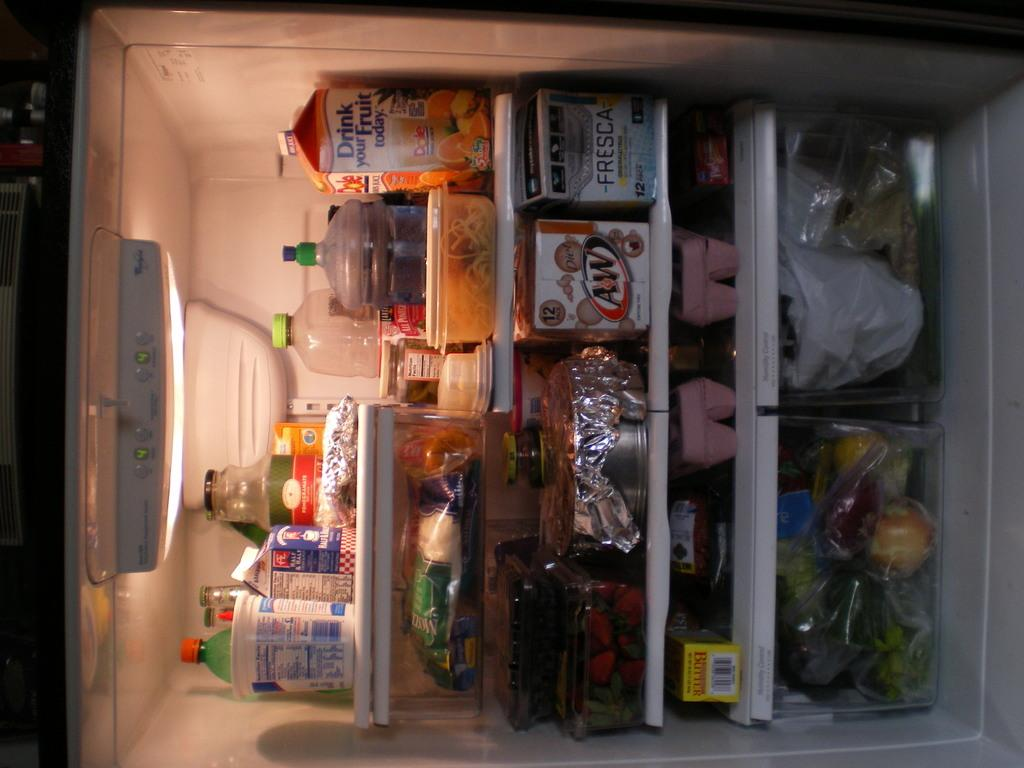Provide a one-sentence caption for the provided image. refrigerator that has a carton of Dole juice and carton of diet a&w. 